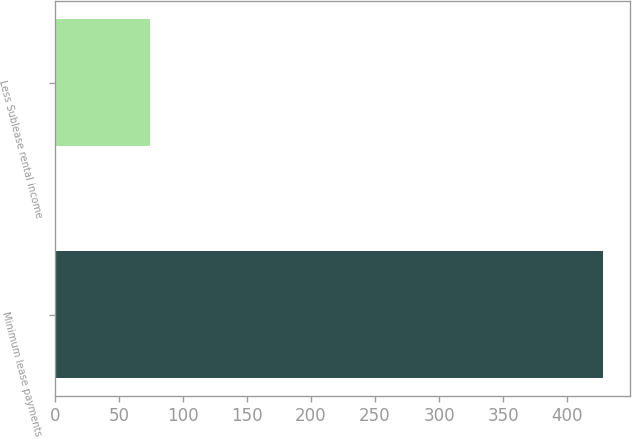Convert chart. <chart><loc_0><loc_0><loc_500><loc_500><bar_chart><fcel>Minimum lease payments<fcel>Less Sublease rental income<nl><fcel>428<fcel>74<nl></chart> 